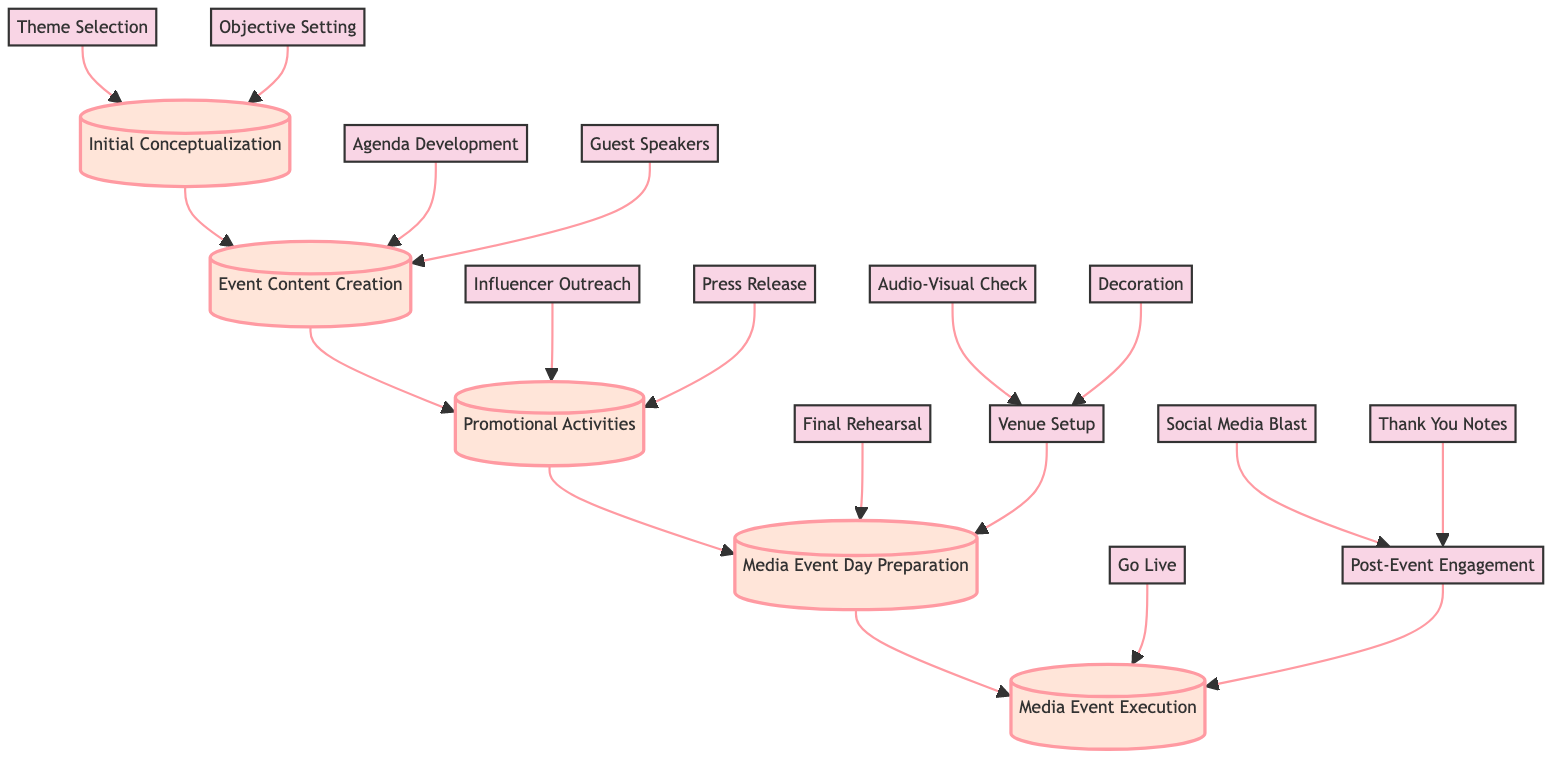What is the first step in the diagram? The first step in the diagram is "Initial Conceptualization." This is represented at the bottom of the flowchart and serves as the starting point for planning a media event.
Answer: Initial Conceptualization How many main stages are there in the flowchart? The flowchart shows five main stages of planning a media event, starting from "Initial Conceptualization" to "Media Event Execution." Each stage is represented by a box connected sequentially.
Answer: 5 What comes after "Event Content Creation"? After "Event Content Creation," the next step in the flowchart is "Promotional Activities." This indicates the sequential flow of tasks involved in planning the media event.
Answer: Promotional Activities Which sub-step falls under "Media Event Day Preparation"? The sub-steps under "Media Event Day Preparation" are "Final Rehearsal" and "Venue Setup." This shows that multiple preparations need to occur during the media event day.
Answer: Final Rehearsal and Venue Setup What is the last action listed under "Media Event Execution"? The last action listed under "Media Event Execution" is "Thank You Notes." This indicates that after the event, there is a follow-up engagement with attendees and other stakeholders.
Answer: Thank You Notes How many sub-steps are there under "Post-Event Engagement"? There are two sub-steps under "Post-Event Engagement," which are "Social Media Blast" and "Thank You Notes." This indicates the actions taken after the event to engage participants and promote the event's highlights.
Answer: 2 What objective comes before "Guest Speakers"? The objective that comes before "Guest Speakers" is "Agenda Development." This shows the sequence in which event content is created, with the agenda needing to be developed first before finalizing speakers.
Answer: Agenda Development What is the connection between "Theme Selection" and "Initial Conceptualization"? "Theme Selection" is a sub-step that leads into "Initial Conceptualization," indicating that choosing a theme is one of the first tasks in defining the event's direction.
Answer: "Theme Selection" leads to "Initial Conceptualization" How does "Audio-Visual Check" relate to "Venue Setup"? "Audio-Visual Check" is a sub-step that falls under "Venue Setup." It indicates that checking audio-visual equipment is part of the wider preparation goals for the event venue.
Answer: "Audio-Visual Check" is part of "Venue Setup." 